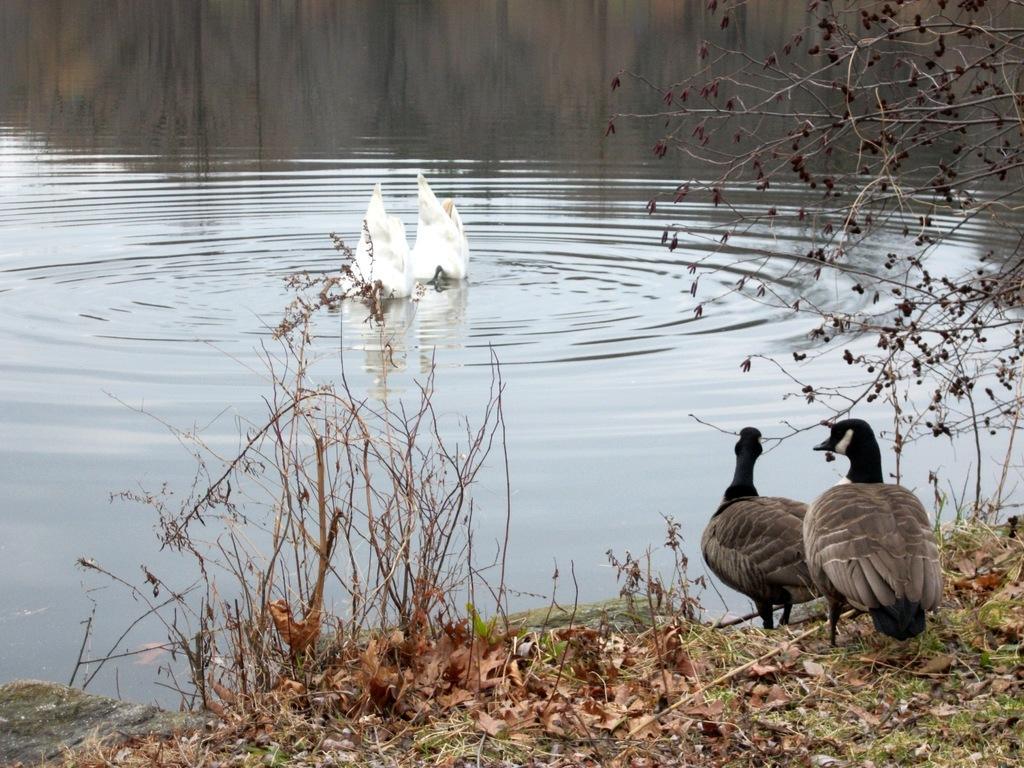Could you give a brief overview of what you see in this image? In this image we can see two birds on the surface of the water. We can also see the other two birds on the grass. We can see the dried plants, trees and also the dried tree. 